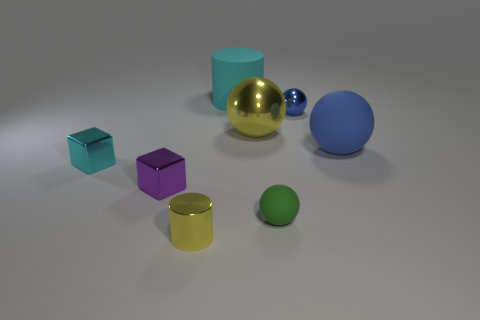Subtract all large yellow metal spheres. How many spheres are left? 3 Subtract all yellow cylinders. How many cylinders are left? 1 Subtract 2 cylinders. How many cylinders are left? 0 Subtract all cylinders. How many objects are left? 6 Subtract all gray spheres. How many purple cubes are left? 1 Subtract all big yellow things. Subtract all large cyan rubber cylinders. How many objects are left? 6 Add 7 large blue rubber balls. How many large blue rubber balls are left? 8 Add 4 purple metal cubes. How many purple metal cubes exist? 5 Add 1 large shiny balls. How many objects exist? 9 Subtract 0 yellow cubes. How many objects are left? 8 